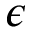<formula> <loc_0><loc_0><loc_500><loc_500>\epsilon</formula> 